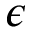<formula> <loc_0><loc_0><loc_500><loc_500>\epsilon</formula> 